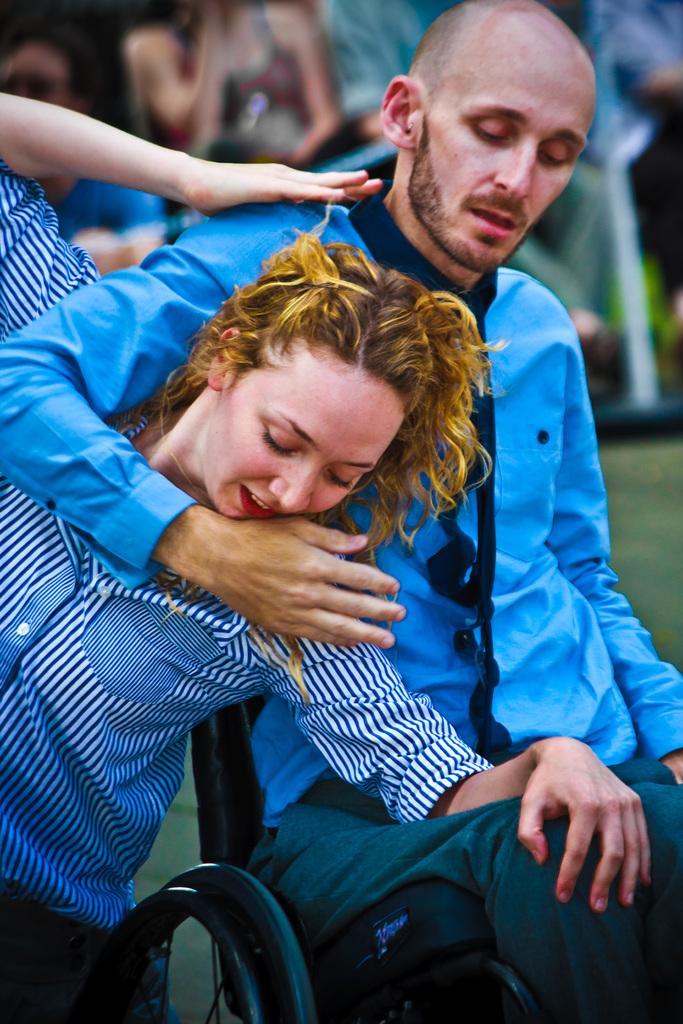How would you summarize this image in a sentence or two? In the image we can see there is a man sitting on the wheelchair and he is holding a woman. Behind there are other people sitting and background of the image is blurred. 